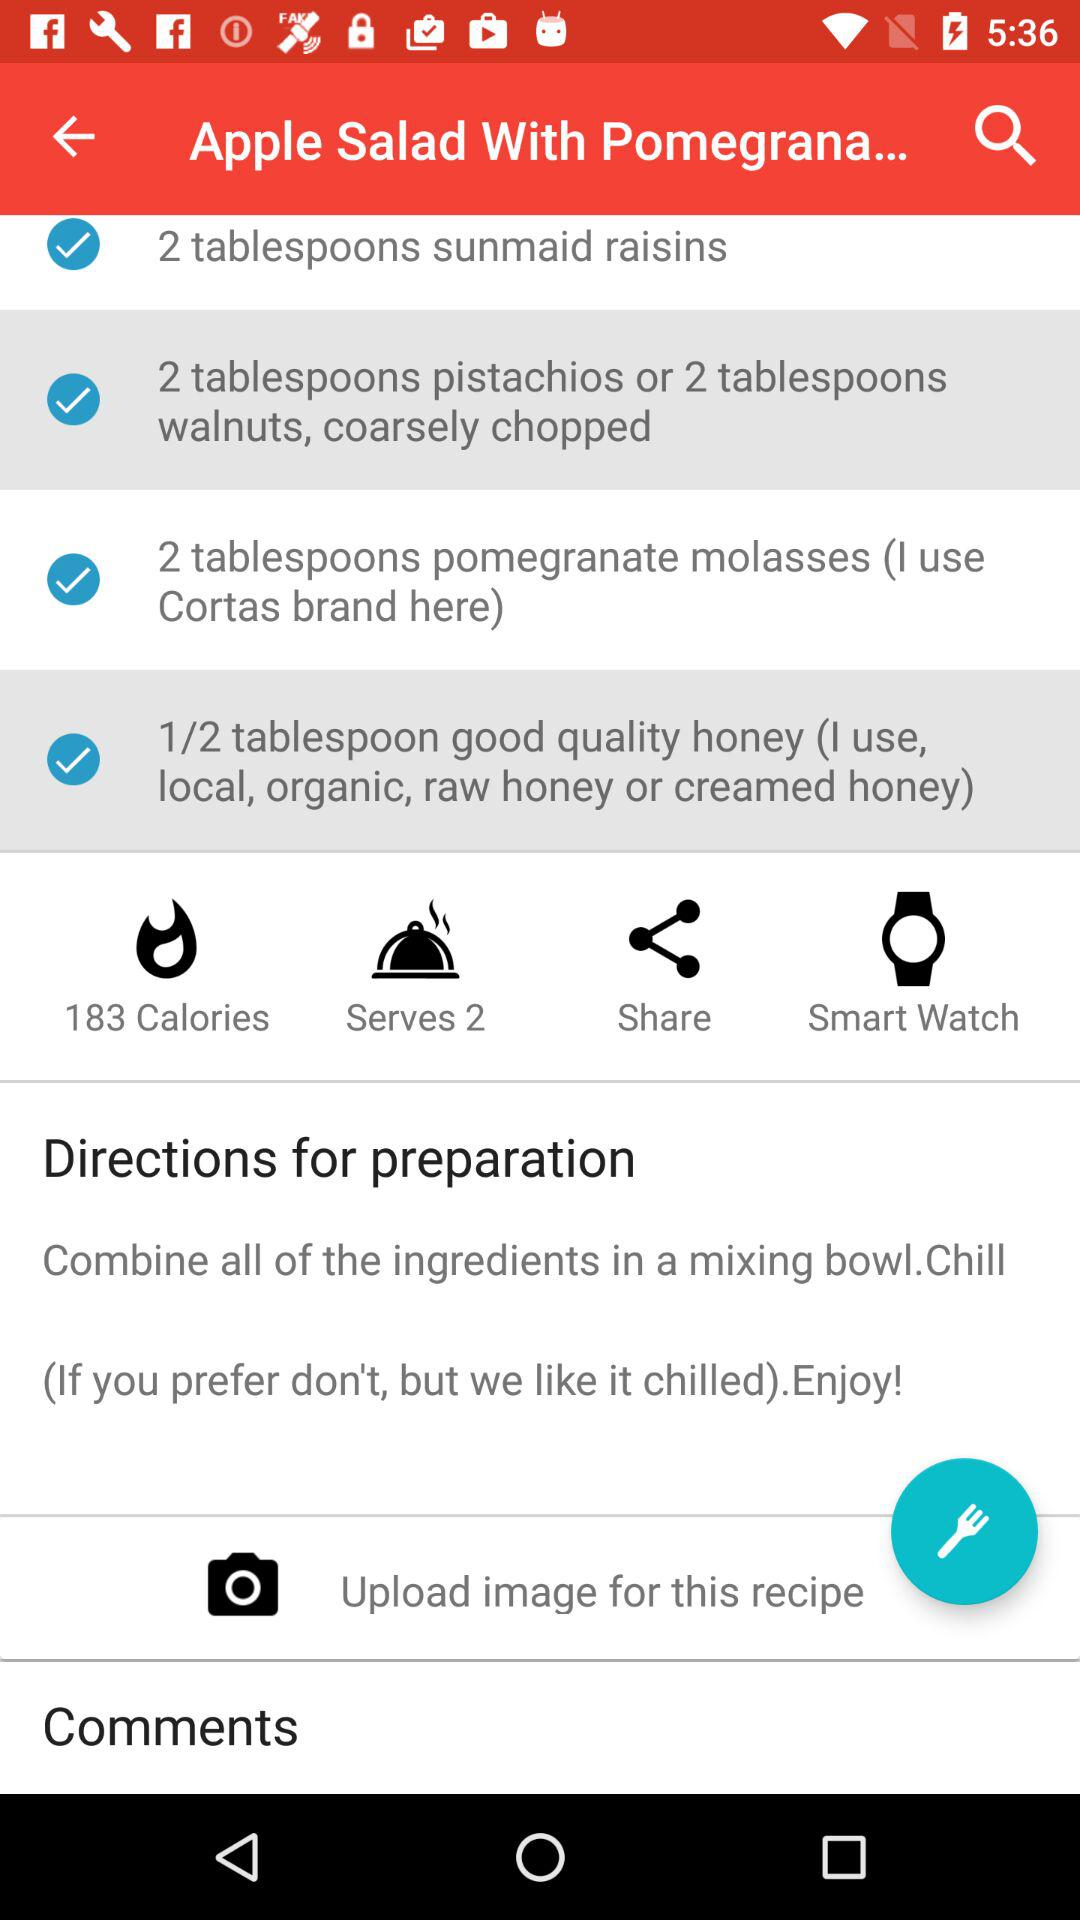How many ingredients are in this recipe?
Answer the question using a single word or phrase. 4 